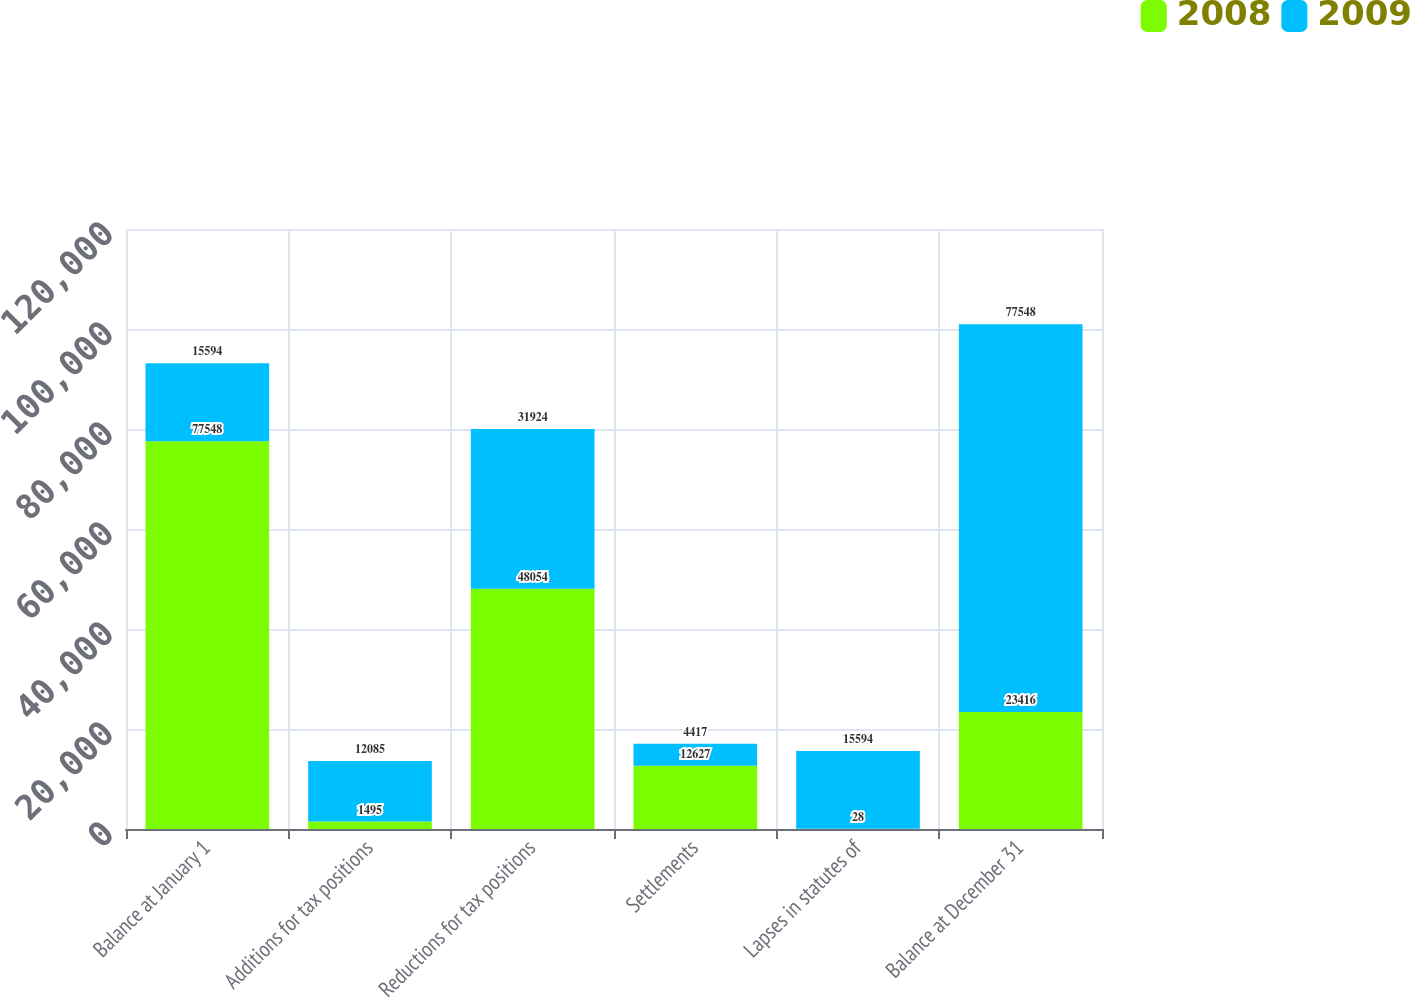Convert chart. <chart><loc_0><loc_0><loc_500><loc_500><stacked_bar_chart><ecel><fcel>Balance at January 1<fcel>Additions for tax positions<fcel>Reductions for tax positions<fcel>Settlements<fcel>Lapses in statutes of<fcel>Balance at December 31<nl><fcel>2008<fcel>77548<fcel>1495<fcel>48054<fcel>12627<fcel>28<fcel>23416<nl><fcel>2009<fcel>15594<fcel>12085<fcel>31924<fcel>4417<fcel>15594<fcel>77548<nl></chart> 